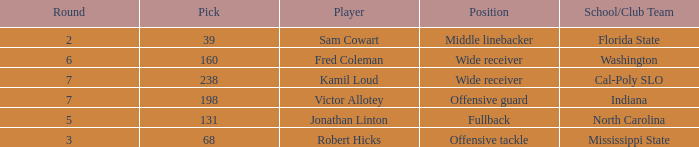Which Round has a School/Club Team of indiana, and a Pick smaller than 198? None. 